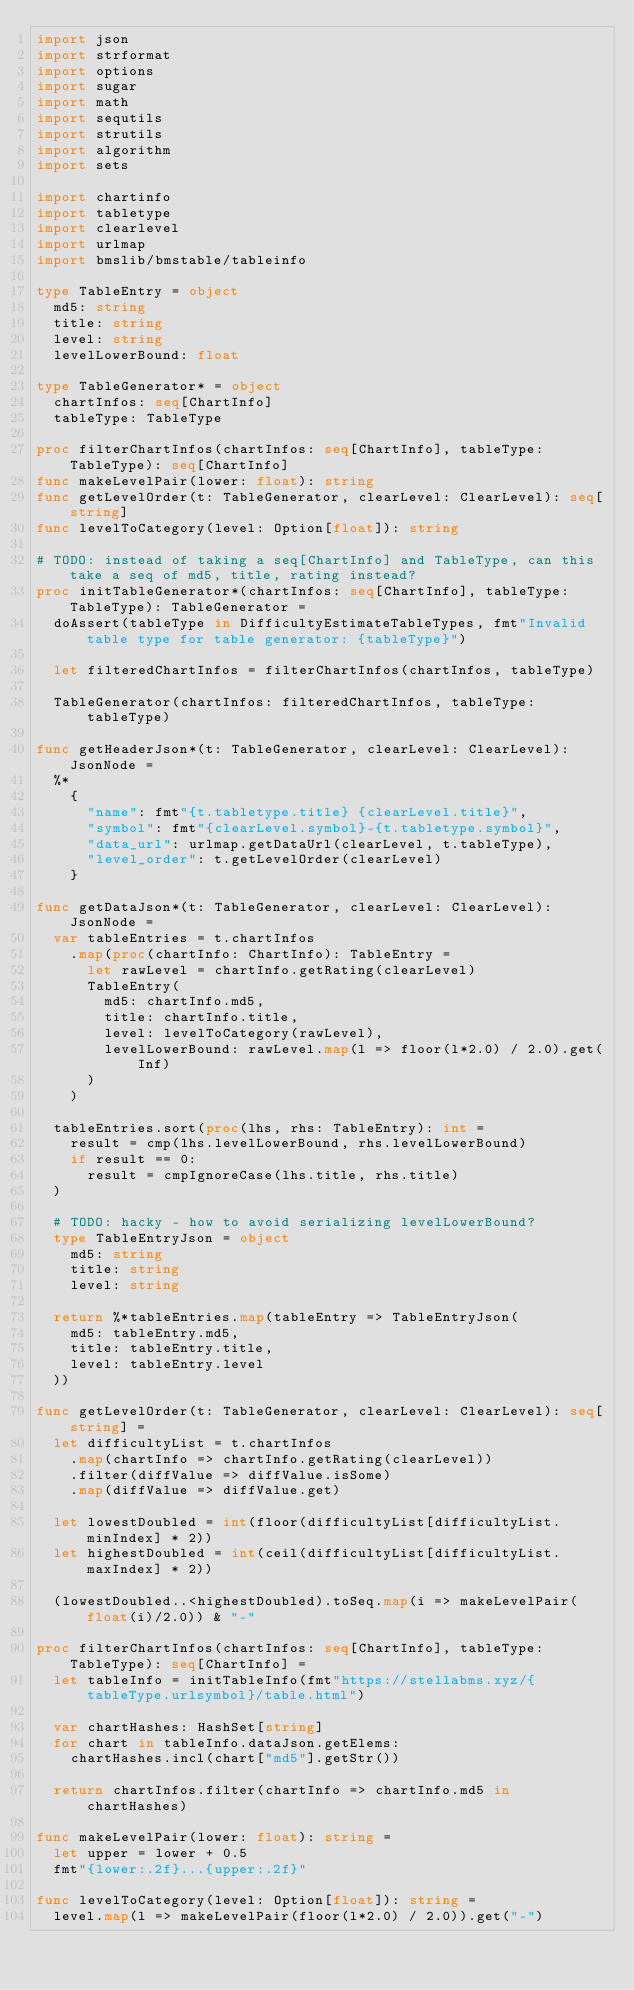Convert code to text. <code><loc_0><loc_0><loc_500><loc_500><_Nim_>import json
import strformat
import options
import sugar
import math
import sequtils
import strutils
import algorithm
import sets

import chartinfo
import tabletype
import clearlevel
import urlmap
import bmslib/bmstable/tableinfo

type TableEntry = object
  md5: string
  title: string
  level: string
  levelLowerBound: float

type TableGenerator* = object
  chartInfos: seq[ChartInfo]
  tableType: TableType

proc filterChartInfos(chartInfos: seq[ChartInfo], tableType: TableType): seq[ChartInfo]
func makeLevelPair(lower: float): string
func getLevelOrder(t: TableGenerator, clearLevel: ClearLevel): seq[string]
func levelToCategory(level: Option[float]): string

# TODO: instead of taking a seq[ChartInfo] and TableType, can this take a seq of md5, title, rating instead?
proc initTableGenerator*(chartInfos: seq[ChartInfo], tableType: TableType): TableGenerator =
  doAssert(tableType in DifficultyEstimateTableTypes, fmt"Invalid table type for table generator: {tableType}")

  let filteredChartInfos = filterChartInfos(chartInfos, tableType)

  TableGenerator(chartInfos: filteredChartInfos, tableType: tableType)

func getHeaderJson*(t: TableGenerator, clearLevel: ClearLevel): JsonNode =
  %*
    {
      "name": fmt"{t.tabletype.title} {clearLevel.title}",
      "symbol": fmt"{clearLevel.symbol}-{t.tabletype.symbol}",
      "data_url": urlmap.getDataUrl(clearLevel, t.tableType),
      "level_order": t.getLevelOrder(clearLevel)
    }

func getDataJson*(t: TableGenerator, clearLevel: ClearLevel): JsonNode =
  var tableEntries = t.chartInfos
    .map(proc(chartInfo: ChartInfo): TableEntry =
      let rawLevel = chartInfo.getRating(clearLevel)
      TableEntry(
        md5: chartInfo.md5,
        title: chartInfo.title,
        level: levelToCategory(rawLevel),
        levelLowerBound: rawLevel.map(l => floor(l*2.0) / 2.0).get(Inf)
      )
    )

  tableEntries.sort(proc(lhs, rhs: TableEntry): int =
    result = cmp(lhs.levelLowerBound, rhs.levelLowerBound)
    if result == 0:
      result = cmpIgnoreCase(lhs.title, rhs.title)
  )

  # TODO: hacky - how to avoid serializing levelLowerBound?
  type TableEntryJson = object
    md5: string
    title: string
    level: string

  return %*tableEntries.map(tableEntry => TableEntryJson(
    md5: tableEntry.md5,
    title: tableEntry.title,
    level: tableEntry.level
  ))

func getLevelOrder(t: TableGenerator, clearLevel: ClearLevel): seq[string] =
  let difficultyList = t.chartInfos
    .map(chartInfo => chartInfo.getRating(clearLevel))
    .filter(diffValue => diffValue.isSome)
    .map(diffValue => diffValue.get)
  
  let lowestDoubled = int(floor(difficultyList[difficultyList.minIndex] * 2))
  let highestDoubled = int(ceil(difficultyList[difficultyList.maxIndex] * 2))

  (lowestDoubled..<highestDoubled).toSeq.map(i => makeLevelPair(float(i)/2.0)) & "-"

proc filterChartInfos(chartInfos: seq[ChartInfo], tableType: TableType): seq[ChartInfo] =
  let tableInfo = initTableInfo(fmt"https://stellabms.xyz/{tableType.urlsymbol}/table.html")

  var chartHashes: HashSet[string]
  for chart in tableInfo.dataJson.getElems:
    chartHashes.incl(chart["md5"].getStr())

  return chartInfos.filter(chartInfo => chartInfo.md5 in chartHashes)

func makeLevelPair(lower: float): string =
  let upper = lower + 0.5
  fmt"{lower:.2f}...{upper:.2f}"

func levelToCategory(level: Option[float]): string =
  level.map(l => makeLevelPair(floor(l*2.0) / 2.0)).get("-")
</code> 